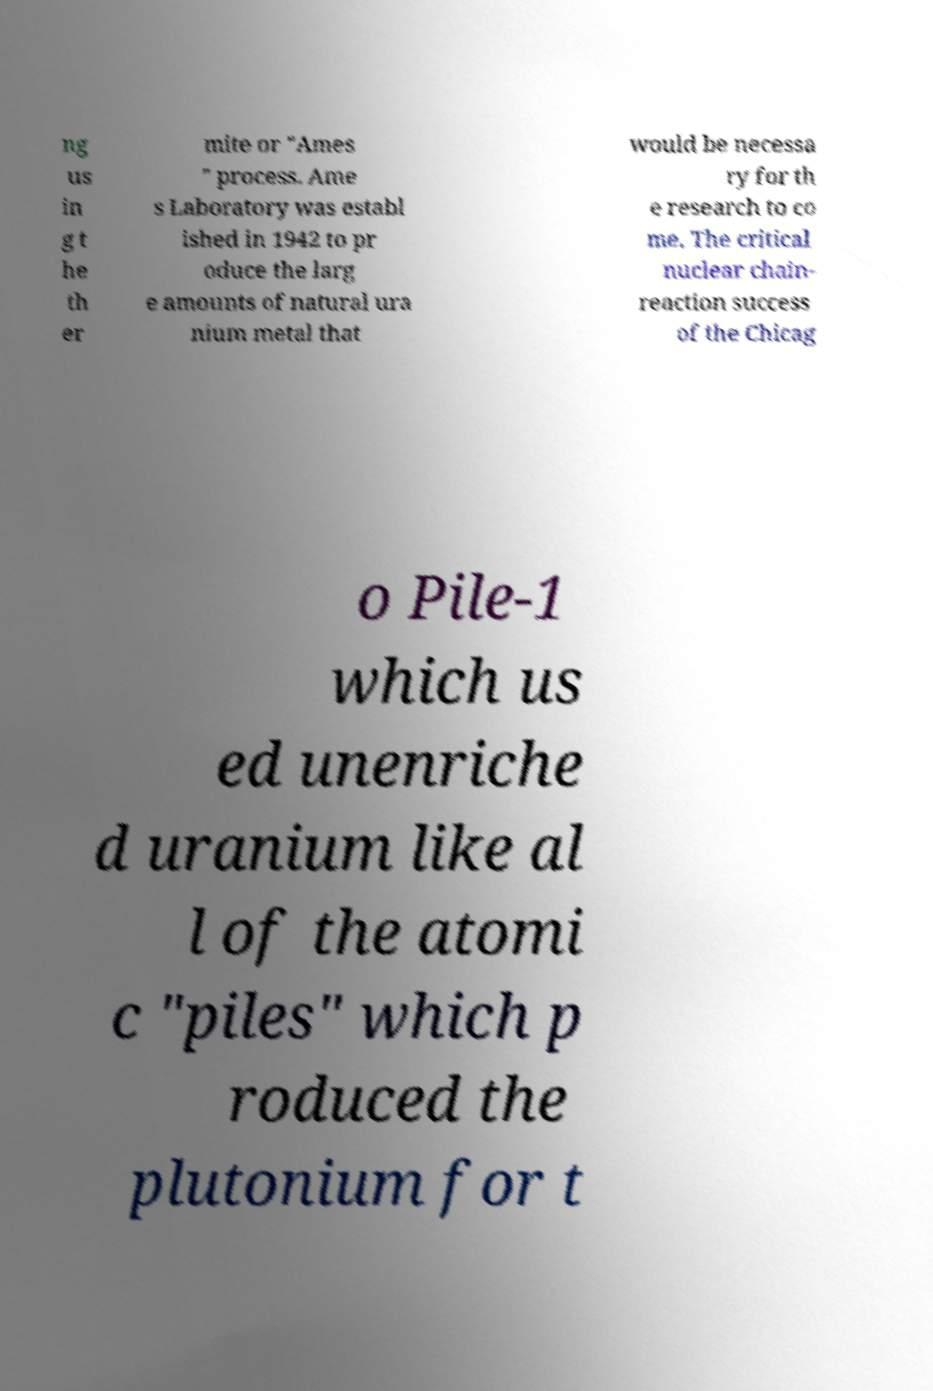Please read and relay the text visible in this image. What does it say? ng us in g t he th er mite or "Ames " process. Ame s Laboratory was establ ished in 1942 to pr oduce the larg e amounts of natural ura nium metal that would be necessa ry for th e research to co me. The critical nuclear chain- reaction success of the Chicag o Pile-1 which us ed unenriche d uranium like al l of the atomi c "piles" which p roduced the plutonium for t 